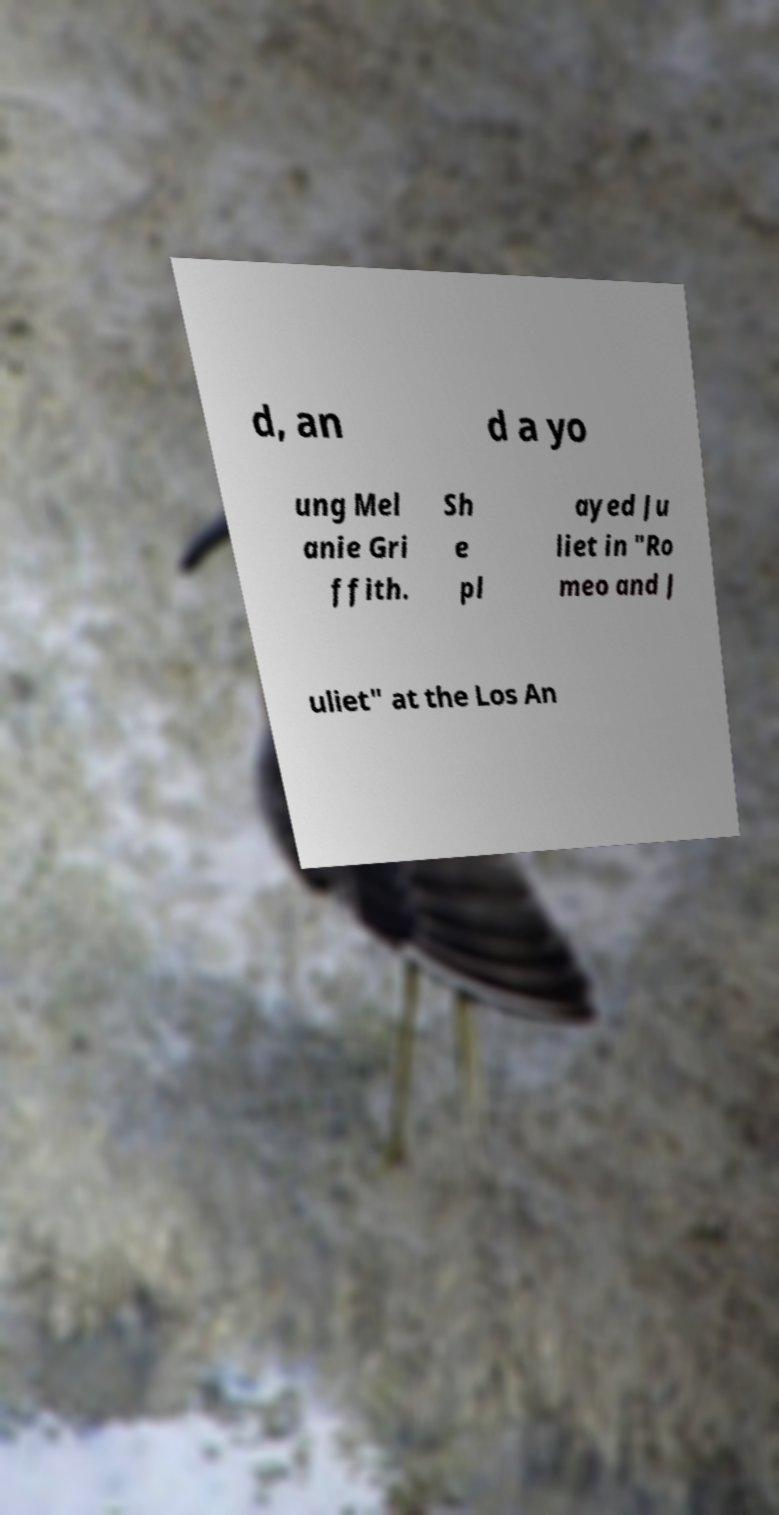Please read and relay the text visible in this image. What does it say? d, an d a yo ung Mel anie Gri ffith. Sh e pl ayed Ju liet in "Ro meo and J uliet" at the Los An 